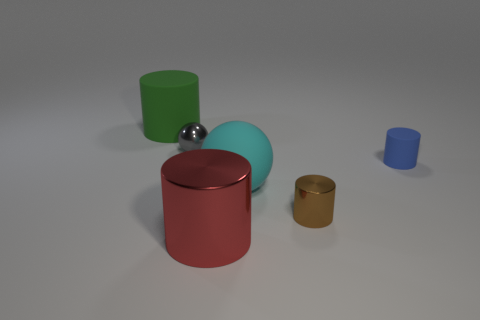Subtract all tiny matte cylinders. How many cylinders are left? 3 Add 2 small cyan spheres. How many objects exist? 8 Subtract all green cylinders. How many cylinders are left? 3 Add 3 large rubber cylinders. How many large rubber cylinders are left? 4 Add 2 cyan matte things. How many cyan matte things exist? 3 Subtract 1 green cylinders. How many objects are left? 5 Subtract all spheres. How many objects are left? 4 Subtract all purple cylinders. Subtract all cyan blocks. How many cylinders are left? 4 Subtract all small blue matte cylinders. Subtract all blue matte things. How many objects are left? 4 